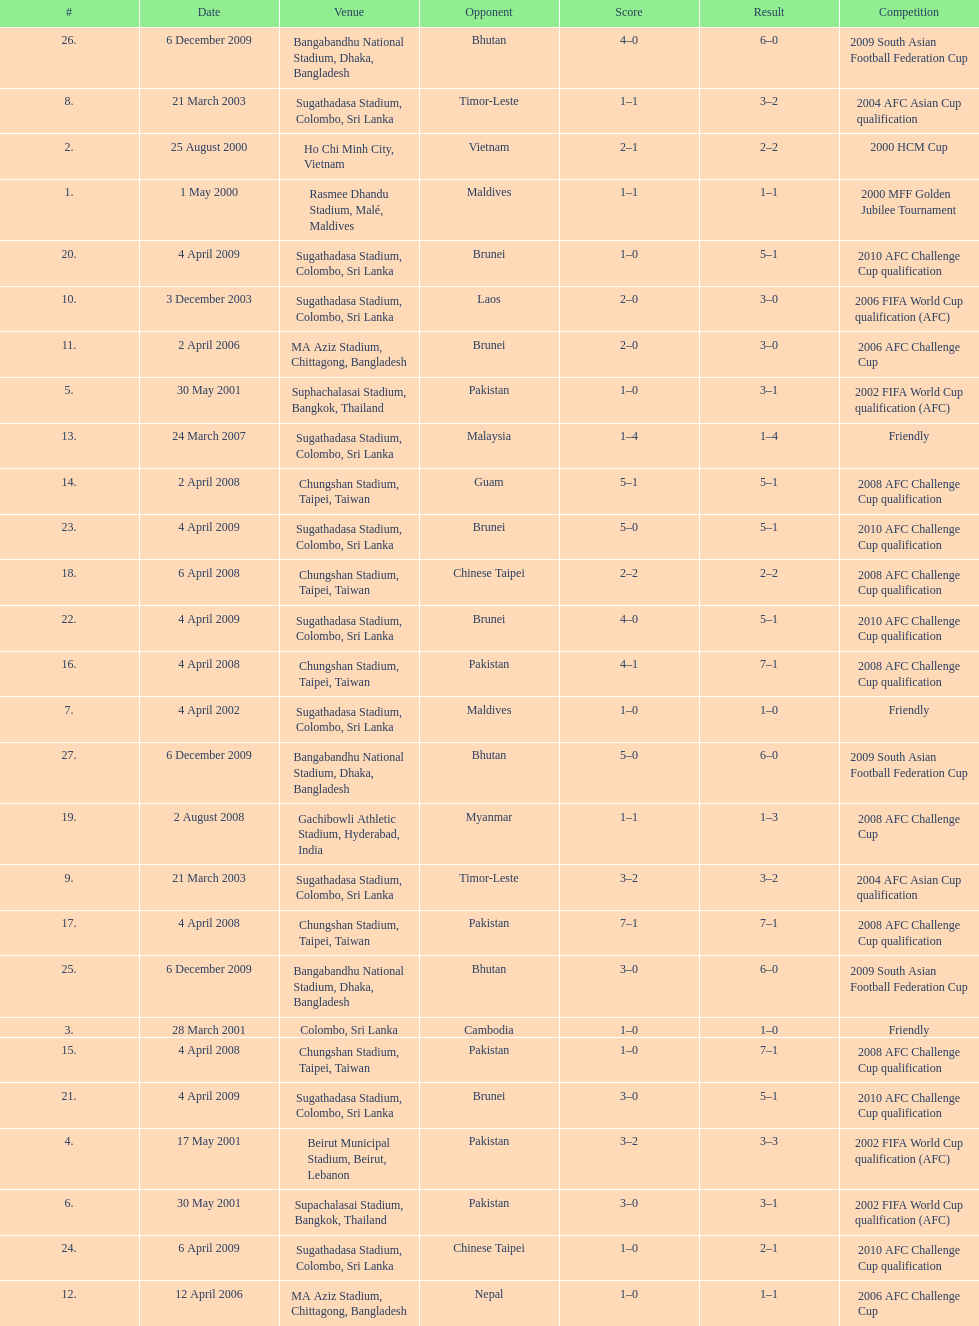What is the top listed venue in the table? Rasmee Dhandu Stadium, Malé, Maldives. Can you parse all the data within this table? {'header': ['#', 'Date', 'Venue', 'Opponent', 'Score', 'Result', 'Competition'], 'rows': [['26.', '6 December 2009', 'Bangabandhu National Stadium, Dhaka, Bangladesh', 'Bhutan', '4–0', '6–0', '2009 South Asian Football Federation Cup'], ['8.', '21 March 2003', 'Sugathadasa Stadium, Colombo, Sri Lanka', 'Timor-Leste', '1–1', '3–2', '2004 AFC Asian Cup qualification'], ['2.', '25 August 2000', 'Ho Chi Minh City, Vietnam', 'Vietnam', '2–1', '2–2', '2000 HCM Cup'], ['1.', '1 May 2000', 'Rasmee Dhandu Stadium, Malé, Maldives', 'Maldives', '1–1', '1–1', '2000 MFF Golden Jubilee Tournament'], ['20.', '4 April 2009', 'Sugathadasa Stadium, Colombo, Sri Lanka', 'Brunei', '1–0', '5–1', '2010 AFC Challenge Cup qualification'], ['10.', '3 December 2003', 'Sugathadasa Stadium, Colombo, Sri Lanka', 'Laos', '2–0', '3–0', '2006 FIFA World Cup qualification (AFC)'], ['11.', '2 April 2006', 'MA Aziz Stadium, Chittagong, Bangladesh', 'Brunei', '2–0', '3–0', '2006 AFC Challenge Cup'], ['5.', '30 May 2001', 'Suphachalasai Stadium, Bangkok, Thailand', 'Pakistan', '1–0', '3–1', '2002 FIFA World Cup qualification (AFC)'], ['13.', '24 March 2007', 'Sugathadasa Stadium, Colombo, Sri Lanka', 'Malaysia', '1–4', '1–4', 'Friendly'], ['14.', '2 April 2008', 'Chungshan Stadium, Taipei, Taiwan', 'Guam', '5–1', '5–1', '2008 AFC Challenge Cup qualification'], ['23.', '4 April 2009', 'Sugathadasa Stadium, Colombo, Sri Lanka', 'Brunei', '5–0', '5–1', '2010 AFC Challenge Cup qualification'], ['18.', '6 April 2008', 'Chungshan Stadium, Taipei, Taiwan', 'Chinese Taipei', '2–2', '2–2', '2008 AFC Challenge Cup qualification'], ['22.', '4 April 2009', 'Sugathadasa Stadium, Colombo, Sri Lanka', 'Brunei', '4–0', '5–1', '2010 AFC Challenge Cup qualification'], ['16.', '4 April 2008', 'Chungshan Stadium, Taipei, Taiwan', 'Pakistan', '4–1', '7–1', '2008 AFC Challenge Cup qualification'], ['7.', '4 April 2002', 'Sugathadasa Stadium, Colombo, Sri Lanka', 'Maldives', '1–0', '1–0', 'Friendly'], ['27.', '6 December 2009', 'Bangabandhu National Stadium, Dhaka, Bangladesh', 'Bhutan', '5–0', '6–0', '2009 South Asian Football Federation Cup'], ['19.', '2 August 2008', 'Gachibowli Athletic Stadium, Hyderabad, India', 'Myanmar', '1–1', '1–3', '2008 AFC Challenge Cup'], ['9.', '21 March 2003', 'Sugathadasa Stadium, Colombo, Sri Lanka', 'Timor-Leste', '3–2', '3–2', '2004 AFC Asian Cup qualification'], ['17.', '4 April 2008', 'Chungshan Stadium, Taipei, Taiwan', 'Pakistan', '7–1', '7–1', '2008 AFC Challenge Cup qualification'], ['25.', '6 December 2009', 'Bangabandhu National Stadium, Dhaka, Bangladesh', 'Bhutan', '3–0', '6–0', '2009 South Asian Football Federation Cup'], ['3.', '28 March 2001', 'Colombo, Sri Lanka', 'Cambodia', '1–0', '1–0', 'Friendly'], ['15.', '4 April 2008', 'Chungshan Stadium, Taipei, Taiwan', 'Pakistan', '1–0', '7–1', '2008 AFC Challenge Cup qualification'], ['21.', '4 April 2009', 'Sugathadasa Stadium, Colombo, Sri Lanka', 'Brunei', '3–0', '5–1', '2010 AFC Challenge Cup qualification'], ['4.', '17 May 2001', 'Beirut Municipal Stadium, Beirut, Lebanon', 'Pakistan', '3–2', '3–3', '2002 FIFA World Cup qualification (AFC)'], ['6.', '30 May 2001', 'Supachalasai Stadium, Bangkok, Thailand', 'Pakistan', '3–0', '3–1', '2002 FIFA World Cup qualification (AFC)'], ['24.', '6 April 2009', 'Sugathadasa Stadium, Colombo, Sri Lanka', 'Chinese Taipei', '1–0', '2–1', '2010 AFC Challenge Cup qualification'], ['12.', '12 April 2006', 'MA Aziz Stadium, Chittagong, Bangladesh', 'Nepal', '1–0', '1–1', '2006 AFC Challenge Cup']]} 